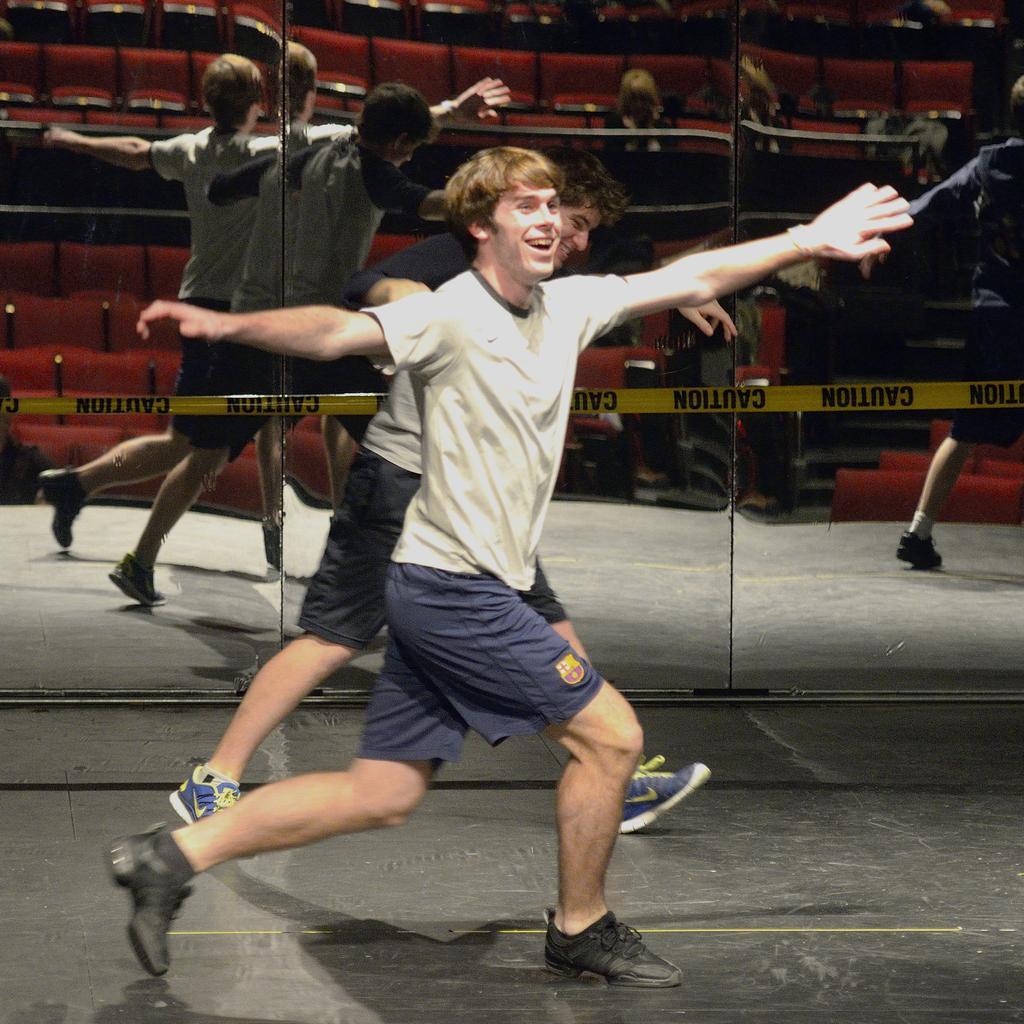Describe this image in one or two sentences. In the middle a man is dancing, he wore a t-shirt, short and black color shoes. This is the glass mirror. 